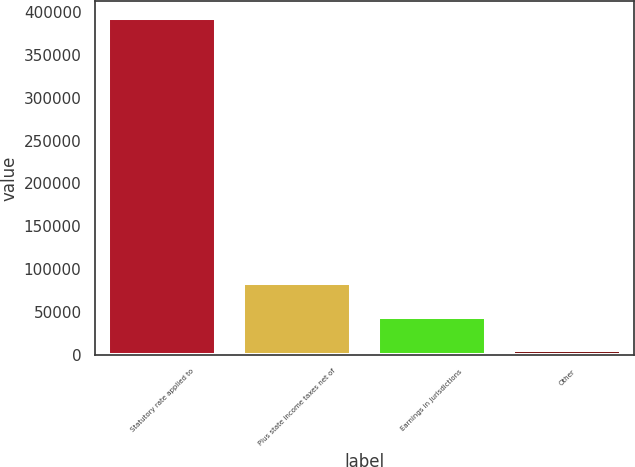Convert chart to OTSL. <chart><loc_0><loc_0><loc_500><loc_500><bar_chart><fcel>Statutory rate applied to<fcel>Plus state income taxes net of<fcel>Earnings in jurisdictions<fcel>Other<nl><fcel>393288<fcel>83545.6<fcel>44827.8<fcel>6110<nl></chart> 